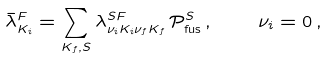Convert formula to latex. <formula><loc_0><loc_0><loc_500><loc_500>\bar { \lambda } ^ { F } _ { K _ { i } } = \sum _ { K _ { f } , S } \lambda ^ { S F } _ { \nu _ { i } K _ { i } \nu _ { f } K _ { f } } \, \mathcal { P } _ { \text {fus} } ^ { S } \, , \quad \nu _ { i } = 0 \, ,</formula> 